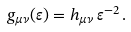Convert formula to latex. <formula><loc_0><loc_0><loc_500><loc_500>g _ { \mu \nu } ( \varepsilon ) = h _ { \mu \nu } \, \varepsilon ^ { - 2 } \, .</formula> 